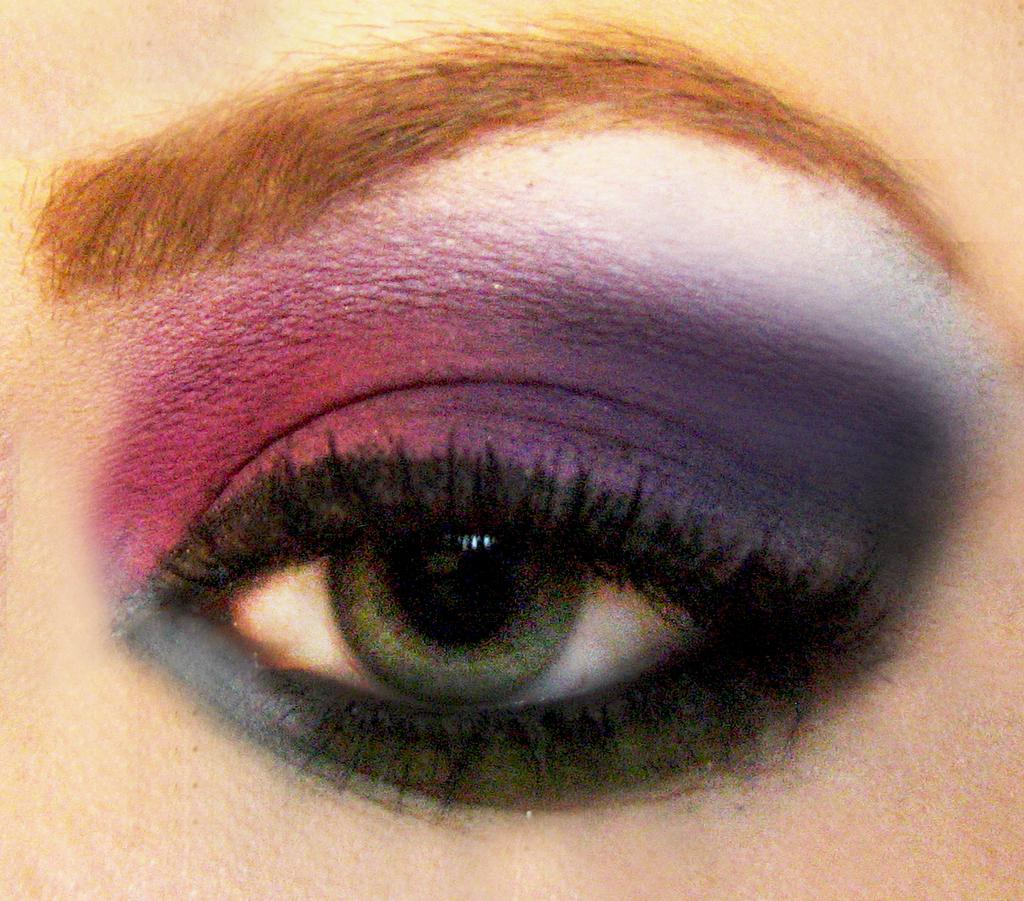What is the main subject of the image? The main subject of the image is a person's eye. What color is present around the eye? The eye has black color around it. What colors can be seen on the top of the eye? There are pink and violet color shades on the top of the eye. What type of whistle can be heard coming from the eye in the image? There is no whistle present in the image, as it features a person's eye with various color shades. 